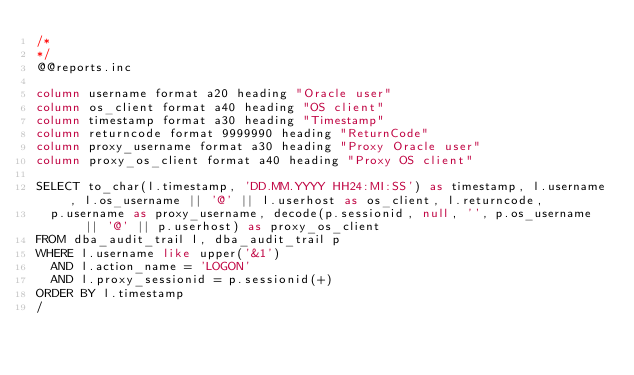Convert code to text. <code><loc_0><loc_0><loc_500><loc_500><_SQL_>/*
*/
@@reports.inc

column username format a20 heading "Oracle user"
column os_client format a40 heading "OS client"
column timestamp format a30 heading "Timestamp"
column returncode format 9999990 heading "ReturnCode"
column proxy_username format a30 heading "Proxy Oracle user"
column proxy_os_client format a40 heading "Proxy OS client"

SELECT to_char(l.timestamp, 'DD.MM.YYYY HH24:MI:SS') as timestamp, l.username, l.os_username || '@' || l.userhost as os_client, l.returncode,
  p.username as proxy_username, decode(p.sessionid, null, '', p.os_username || '@' || p.userhost) as proxy_os_client
FROM dba_audit_trail l, dba_audit_trail p
WHERE l.username like upper('&1')
  AND l.action_name = 'LOGON'
  AND l.proxy_sessionid = p.sessionid(+)
ORDER BY l.timestamp
/
</code> 